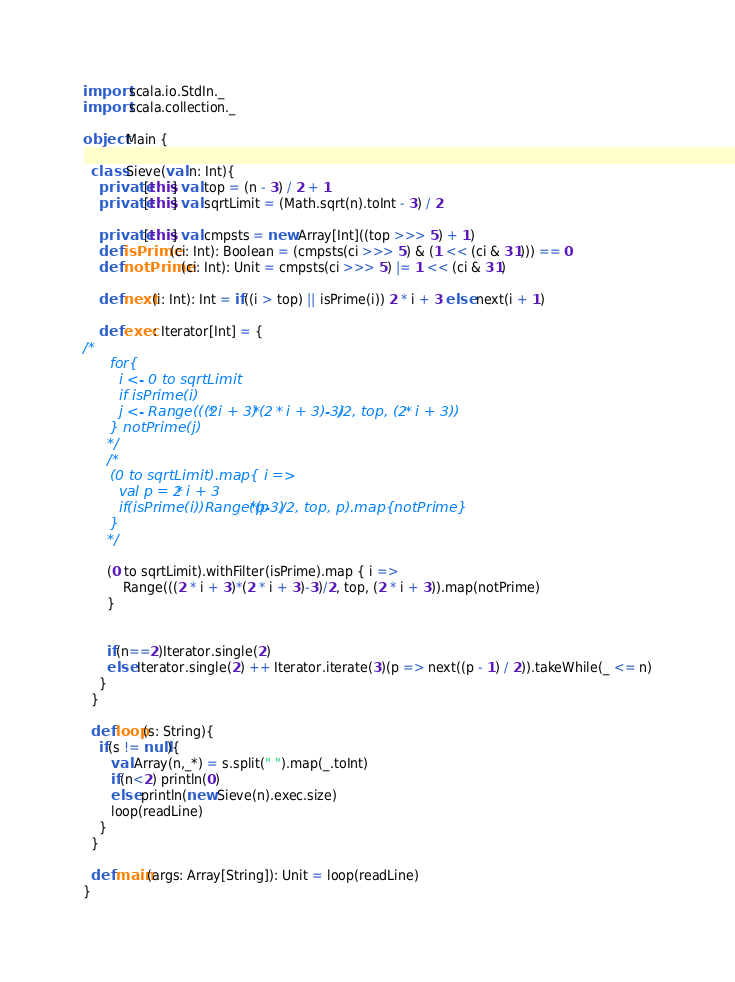<code> <loc_0><loc_0><loc_500><loc_500><_Scala_>import scala.io.StdIn._
import scala.collection._

object Main {

  class Sieve(val n: Int){
    private[this] val top = (n - 3) / 2 + 1
    private[this] val sqrtLimit = (Math.sqrt(n).toInt - 3) / 2

    private[this] val cmpsts = new Array[Int]((top >>> 5) + 1)
    def isPrime(ci: Int): Boolean = (cmpsts(ci >>> 5) & (1 << (ci & 31))) == 0
    def notPrime(ci: Int): Unit = cmpsts(ci >>> 5) |= 1 << (ci & 31)

    def next(i: Int): Int = if((i > top) || isPrime(i)) 2 * i + 3 else next(i + 1)

    def exec: Iterator[Int] = {
/*
      for{
        i <- 0 to sqrtLimit
        if isPrime(i)
        j <- Range(((2 * i + 3)*(2 * i + 3)-3)/2, top, (2 * i + 3))
      } notPrime(j)
      */
      /*
      (0 to sqrtLimit).map{ i =>
        val p = 2 * i + 3
        if(isPrime(i))Range((p*p-3)/2, top, p).map{notPrime}
      }
      */

      (0 to sqrtLimit).withFilter(isPrime).map { i =>
          Range(((2 * i + 3)*(2 * i + 3)-3)/2, top, (2 * i + 3)).map(notPrime)
      }


      if(n==2)Iterator.single(2)
      else Iterator.single(2) ++ Iterator.iterate(3)(p => next((p - 1) / 2)).takeWhile(_ <= n)
    }
  }

  def loop(s: String){
    if(s != null){
       val Array(n,_*) = s.split(" ").map(_.toInt)
       if(n<2) println(0)
       else println(new Sieve(n).exec.size)
       loop(readLine)
    }
  }

  def main(args: Array[String]): Unit = loop(readLine)
}</code> 